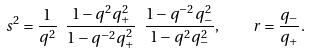Convert formula to latex. <formula><loc_0><loc_0><loc_500><loc_500>s ^ { 2 } = \frac { 1 } { q ^ { 2 } } \ \frac { 1 - q ^ { 2 } q _ { + } ^ { 2 } } { 1 - q ^ { - 2 } q _ { + } ^ { 2 } } \ \frac { 1 - q ^ { - 2 } q _ { - } ^ { 2 } } { 1 - q ^ { 2 } q _ { - } ^ { 2 } } , \quad r = \frac { q _ { - } } { q _ { + } } .</formula> 